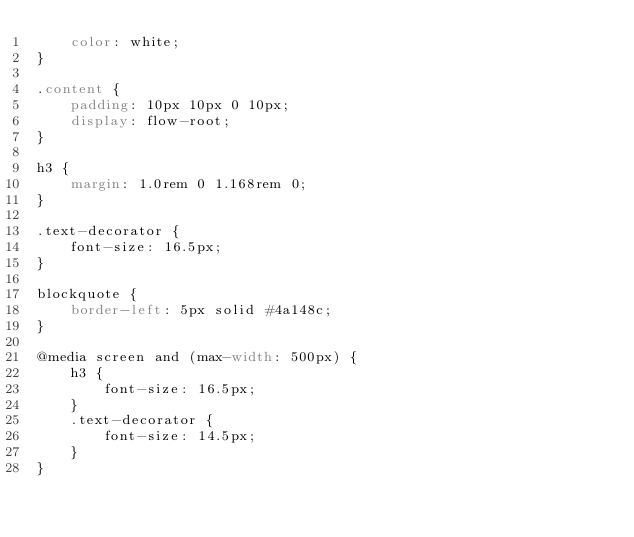<code> <loc_0><loc_0><loc_500><loc_500><_CSS_>    color: white;
}

.content {
    padding: 10px 10px 0 10px;
    display: flow-root;
}

h3 {
    margin: 1.0rem 0 1.168rem 0;
}

.text-decorator {
    font-size: 16.5px;
}

blockquote {
    border-left: 5px solid #4a148c;
}

@media screen and (max-width: 500px) {
    h3 {
        font-size: 16.5px;
    }
    .text-decorator {
        font-size: 14.5px;
    }
}
</code> 